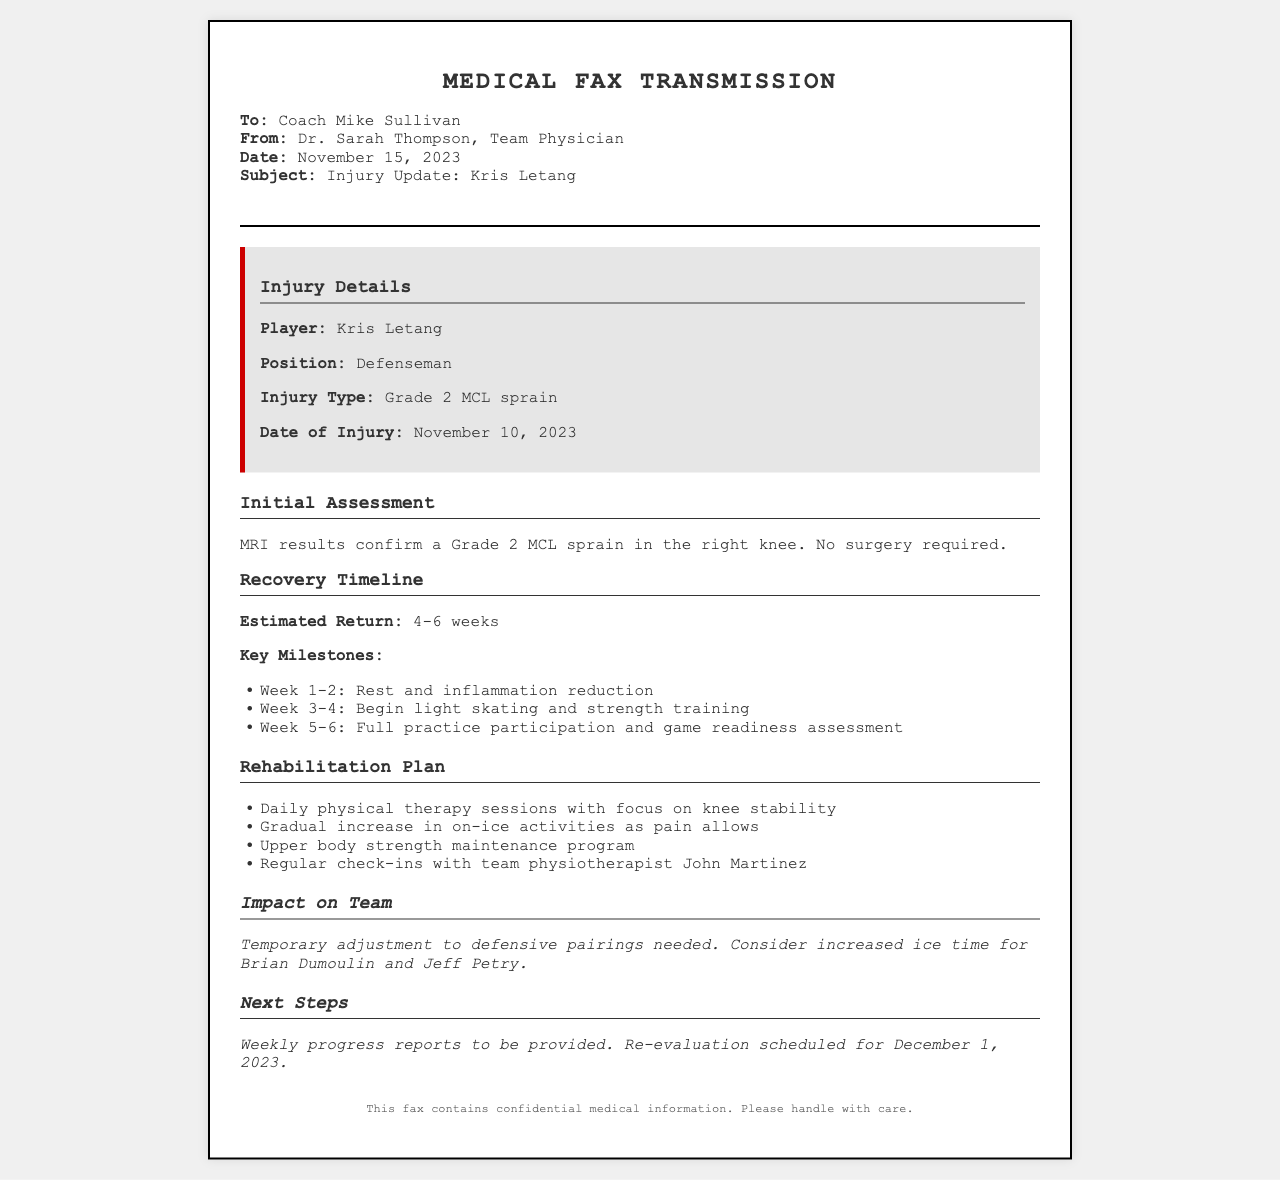what is the player's name? The player's name is mentioned in the injury details section of the document.
Answer: Kris Letang what type of injury does Kris Letang have? The type of injury is specified in the injury details section.
Answer: Grade 2 MCL sprain when was the injury sustained? The date of the injury is provided in the injury details.
Answer: November 10, 2023 what is the estimated return timeline? The estimated return is highlighted in the recovery timeline section.
Answer: 4-6 weeks what are the key milestones during recovery? The key milestones are listed under the recovery timeline with specific weeks outlined.
Answer: Rest, light skating, full practice who is the team's physiotherapist? The physiotherapist's name is mentioned in the rehabilitation plan section.
Answer: John Martinez what adjustments are needed for the team? The impact on the team section outlines adjustments needed due to the player's injury.
Answer: Temporary adjustment to defensive pairings when is the next re-evaluation scheduled? The re-evaluation date is specified in the next steps section.
Answer: December 1, 2023 who sent the fax? The sender of the fax is identified in the header details.
Answer: Dr. Sarah Thompson, Team Physician 